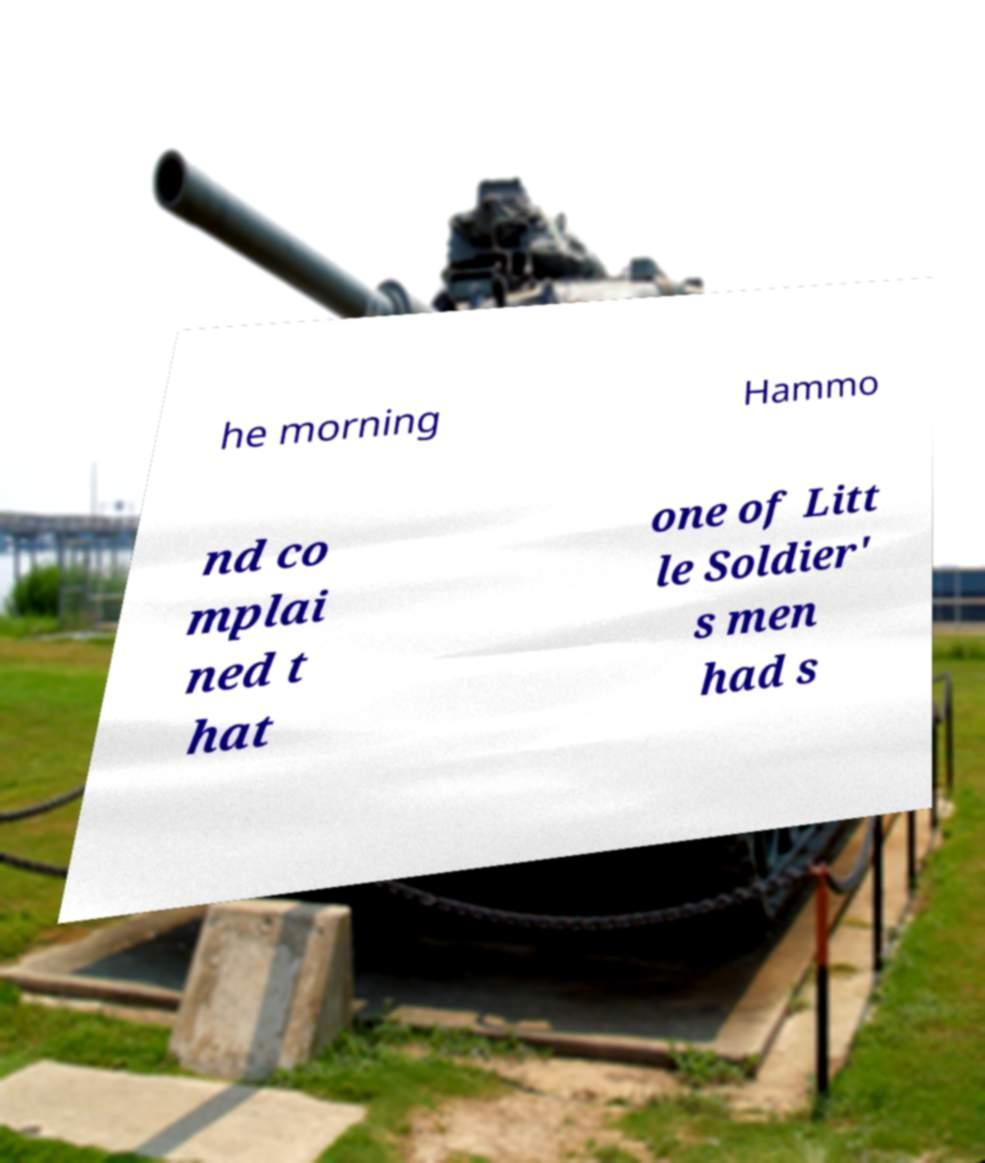What messages or text are displayed in this image? I need them in a readable, typed format. he morning Hammo nd co mplai ned t hat one of Litt le Soldier' s men had s 